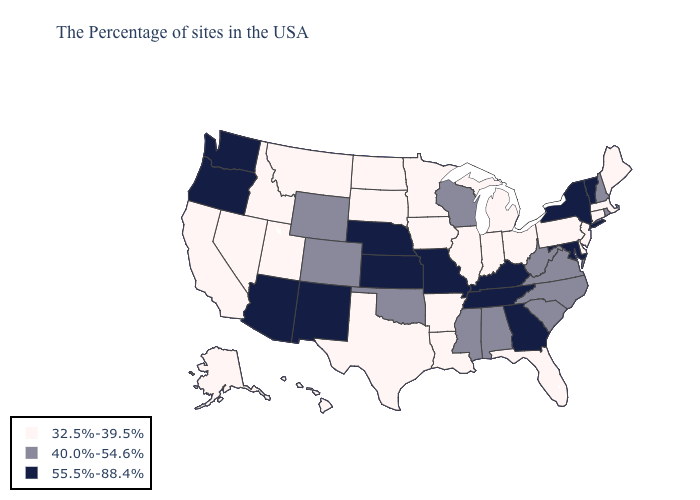Which states have the lowest value in the South?
Short answer required. Delaware, Florida, Louisiana, Arkansas, Texas. What is the value of Nevada?
Answer briefly. 32.5%-39.5%. Does New Hampshire have a lower value than Minnesota?
Keep it brief. No. Does Georgia have the highest value in the USA?
Short answer required. Yes. Name the states that have a value in the range 40.0%-54.6%?
Be succinct. Rhode Island, New Hampshire, Virginia, North Carolina, South Carolina, West Virginia, Alabama, Wisconsin, Mississippi, Oklahoma, Wyoming, Colorado. Does the map have missing data?
Keep it brief. No. What is the value of Colorado?
Give a very brief answer. 40.0%-54.6%. What is the value of Tennessee?
Write a very short answer. 55.5%-88.4%. What is the value of Idaho?
Concise answer only. 32.5%-39.5%. Name the states that have a value in the range 40.0%-54.6%?
Concise answer only. Rhode Island, New Hampshire, Virginia, North Carolina, South Carolina, West Virginia, Alabama, Wisconsin, Mississippi, Oklahoma, Wyoming, Colorado. What is the highest value in states that border Delaware?
Quick response, please. 55.5%-88.4%. Name the states that have a value in the range 55.5%-88.4%?
Quick response, please. Vermont, New York, Maryland, Georgia, Kentucky, Tennessee, Missouri, Kansas, Nebraska, New Mexico, Arizona, Washington, Oregon. Among the states that border Oregon , does Idaho have the lowest value?
Short answer required. Yes. What is the highest value in the USA?
Concise answer only. 55.5%-88.4%. Name the states that have a value in the range 55.5%-88.4%?
Quick response, please. Vermont, New York, Maryland, Georgia, Kentucky, Tennessee, Missouri, Kansas, Nebraska, New Mexico, Arizona, Washington, Oregon. 